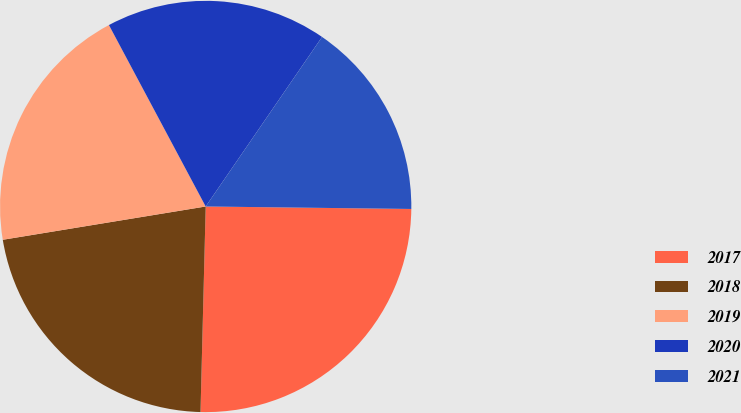<chart> <loc_0><loc_0><loc_500><loc_500><pie_chart><fcel>2017<fcel>2018<fcel>2019<fcel>2020<fcel>2021<nl><fcel>25.21%<fcel>22.01%<fcel>19.79%<fcel>17.37%<fcel>15.62%<nl></chart> 